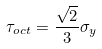Convert formula to latex. <formula><loc_0><loc_0><loc_500><loc_500>\tau _ { o c t } = \frac { \sqrt { 2 } } { 3 } \sigma _ { y }</formula> 